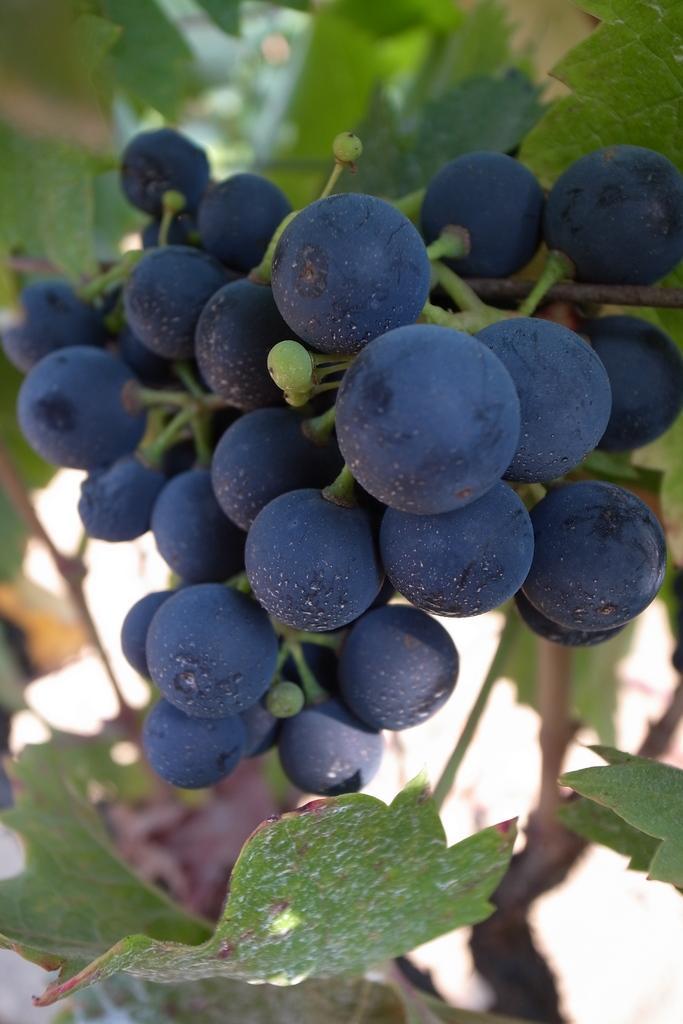Please provide a concise description of this image. In this image I can see there are few fruits attached to the stem of a plant and there are few leaves and the background of the image is blurred. 